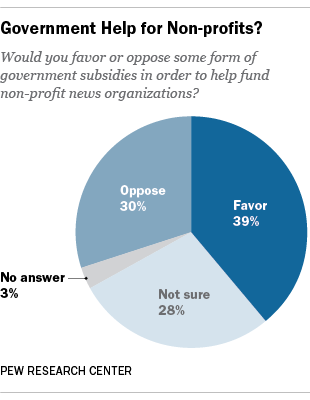Highlight a few significant elements in this photo. The value that represents the largest percentage of the graph is "Favorable. The total value between "oppose" and "favor" is 69. 